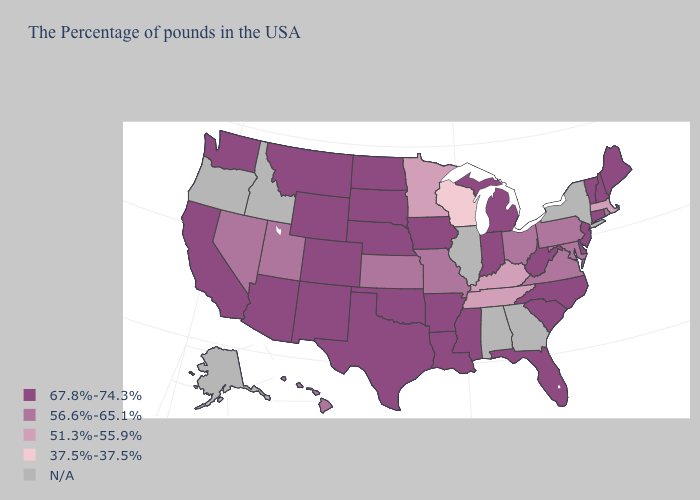Does Indiana have the lowest value in the USA?
Answer briefly. No. Does Wisconsin have the lowest value in the USA?
Give a very brief answer. Yes. Name the states that have a value in the range 56.6%-65.1%?
Keep it brief. Rhode Island, Maryland, Pennsylvania, Virginia, Ohio, Missouri, Kansas, Utah, Nevada, Hawaii. Name the states that have a value in the range 67.8%-74.3%?
Concise answer only. Maine, New Hampshire, Vermont, Connecticut, New Jersey, Delaware, North Carolina, South Carolina, West Virginia, Florida, Michigan, Indiana, Mississippi, Louisiana, Arkansas, Iowa, Nebraska, Oklahoma, Texas, South Dakota, North Dakota, Wyoming, Colorado, New Mexico, Montana, Arizona, California, Washington. Name the states that have a value in the range 56.6%-65.1%?
Write a very short answer. Rhode Island, Maryland, Pennsylvania, Virginia, Ohio, Missouri, Kansas, Utah, Nevada, Hawaii. Does Washington have the lowest value in the West?
Give a very brief answer. No. Does Rhode Island have the highest value in the USA?
Keep it brief. No. What is the highest value in the South ?
Quick response, please. 67.8%-74.3%. Name the states that have a value in the range 51.3%-55.9%?
Give a very brief answer. Massachusetts, Kentucky, Tennessee, Minnesota. Name the states that have a value in the range 51.3%-55.9%?
Give a very brief answer. Massachusetts, Kentucky, Tennessee, Minnesota. Among the states that border Kentucky , which have the highest value?
Keep it brief. West Virginia, Indiana. Name the states that have a value in the range 56.6%-65.1%?
Concise answer only. Rhode Island, Maryland, Pennsylvania, Virginia, Ohio, Missouri, Kansas, Utah, Nevada, Hawaii. What is the value of Rhode Island?
Short answer required. 56.6%-65.1%. 